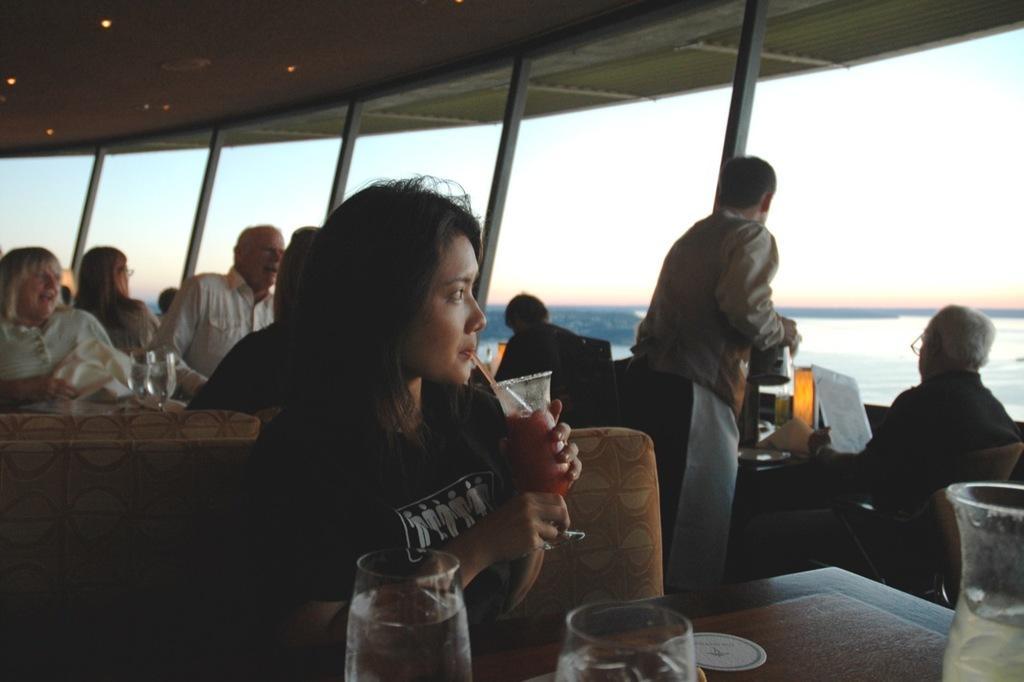Please provide a concise description of this image. In this picture we can see a group of people, glasses, tables, chairs, paper, shelter and some objects and in the background we can see the water and the sky. 